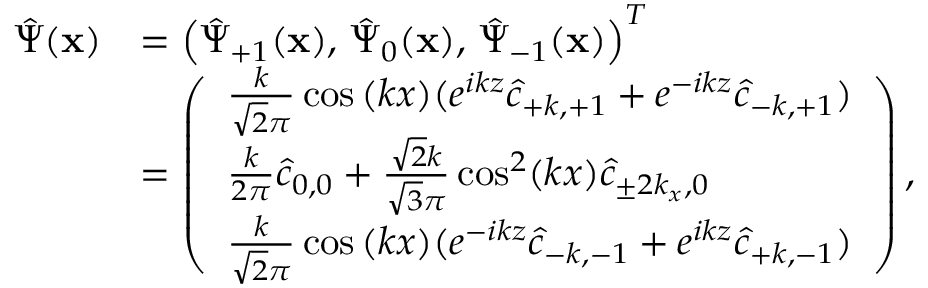<formula> <loc_0><loc_0><loc_500><loc_500>\begin{array} { r l } { \hat { \Psi } ( x ) } & { = \left ( \hat { \Psi } _ { + 1 } ( x ) , \, \hat { \Psi } _ { 0 } ( x ) , \, \hat { \Psi } _ { - 1 } ( x ) \right ) ^ { T } } \\ & { = \left ( \begin{array} { l } { \frac { k } { \sqrt { 2 } \pi } \cos { ( k x ) } ( e ^ { i k z } \hat { c } _ { + k , + 1 } + e ^ { - i k z } \hat { c } _ { - k , + 1 } ) } \\ { \frac { k } { 2 \pi } \hat { c } _ { 0 , 0 } + \frac { \sqrt { 2 } k } { \sqrt { 3 } \pi } \cos ^ { 2 } ( k x ) \hat { c } _ { \pm 2 k _ { x } , 0 } } \\ { \frac { k } { \sqrt { 2 } \pi } \cos { ( k x ) } ( e ^ { - i k z } \hat { c } _ { - k , - 1 } + e ^ { i k z } \hat { c } _ { + k , - 1 } ) } \end{array} \right ) , } \end{array}</formula> 